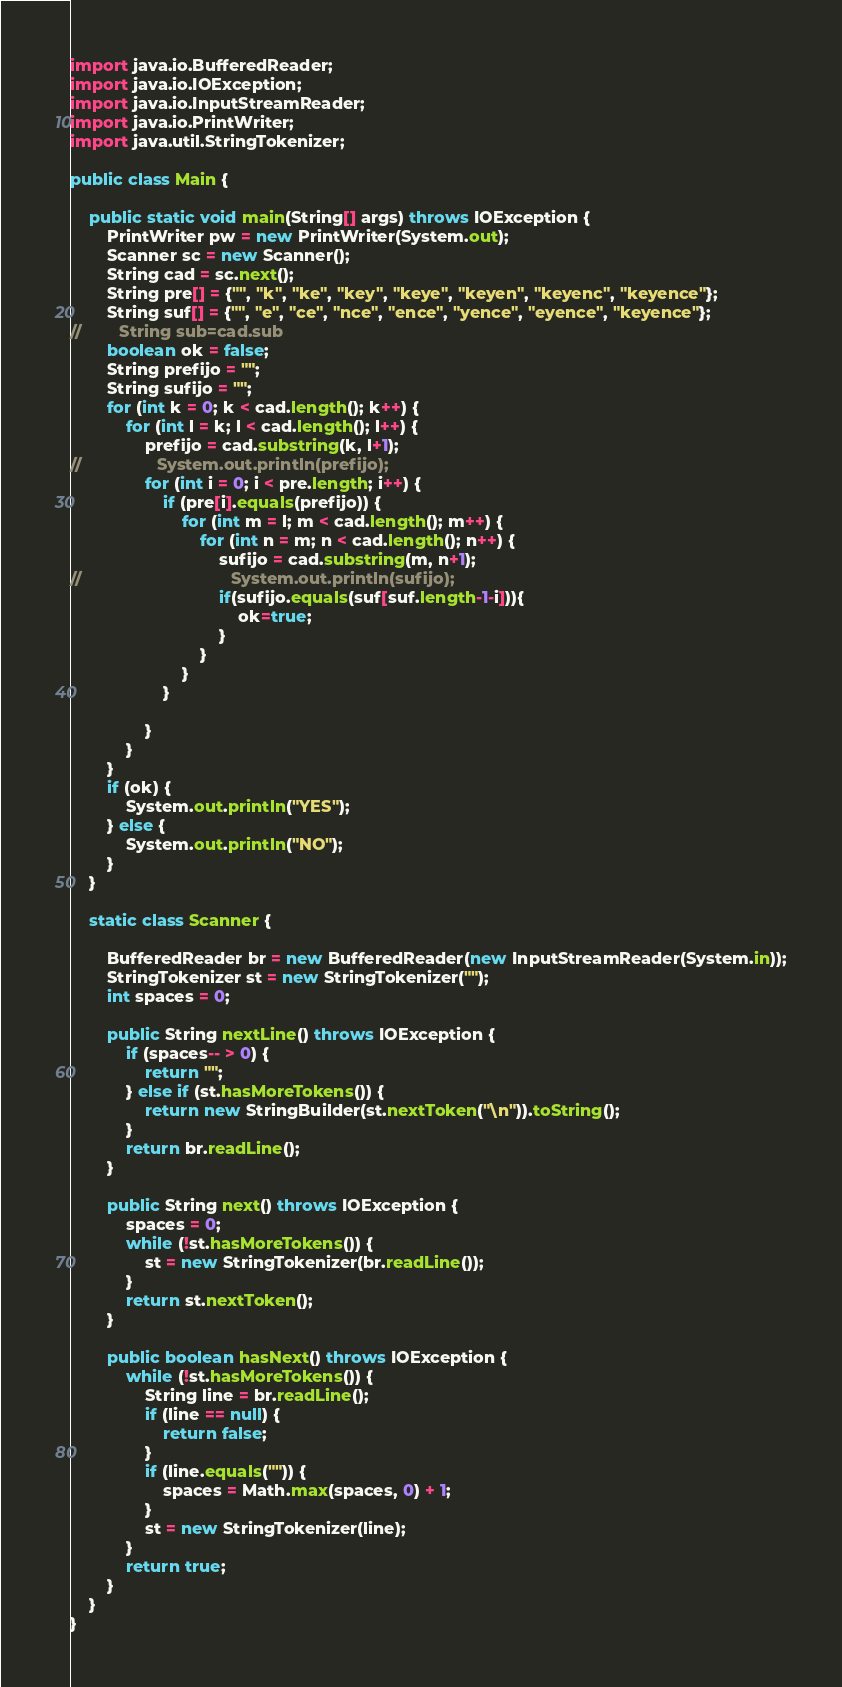<code> <loc_0><loc_0><loc_500><loc_500><_Java_>
import java.io.BufferedReader;
import java.io.IOException;
import java.io.InputStreamReader;
import java.io.PrintWriter;
import java.util.StringTokenizer;

public class Main {

    public static void main(String[] args) throws IOException {
        PrintWriter pw = new PrintWriter(System.out);
        Scanner sc = new Scanner();
        String cad = sc.next();
        String pre[] = {"", "k", "ke", "key", "keye", "keyen", "keyenc", "keyence"};
        String suf[] = {"", "e", "ce", "nce", "ence", "yence", "eyence", "keyence"};
//        String sub=cad.sub
        boolean ok = false;
        String prefijo = "";
        String sufijo = "";
        for (int k = 0; k < cad.length(); k++) {
            for (int l = k; l < cad.length(); l++) {
                prefijo = cad.substring(k, l+1);
//                System.out.println(prefijo);
                for (int i = 0; i < pre.length; i++) {
                    if (pre[i].equals(prefijo)) {
                        for (int m = l; m < cad.length(); m++) {
                            for (int n = m; n < cad.length(); n++) {
                                sufijo = cad.substring(m, n+1);
//                                System.out.println(sufijo);
                                if(sufijo.equals(suf[suf.length-1-i])){
                                    ok=true;
                                }
                            }
                        }
                    }

                }
            }
        }
        if (ok) {
            System.out.println("YES");
        } else {
            System.out.println("NO");
        }
    }

    static class Scanner {

        BufferedReader br = new BufferedReader(new InputStreamReader(System.in));
        StringTokenizer st = new StringTokenizer("");
        int spaces = 0;

        public String nextLine() throws IOException {
            if (spaces-- > 0) {
                return "";
            } else if (st.hasMoreTokens()) {
                return new StringBuilder(st.nextToken("\n")).toString();
            }
            return br.readLine();
        }

        public String next() throws IOException {
            spaces = 0;
            while (!st.hasMoreTokens()) {
                st = new StringTokenizer(br.readLine());
            }
            return st.nextToken();
        }

        public boolean hasNext() throws IOException {
            while (!st.hasMoreTokens()) {
                String line = br.readLine();
                if (line == null) {
                    return false;
                }
                if (line.equals("")) {
                    spaces = Math.max(spaces, 0) + 1;
                }
                st = new StringTokenizer(line);
            }
            return true;
        }
    }
}
</code> 